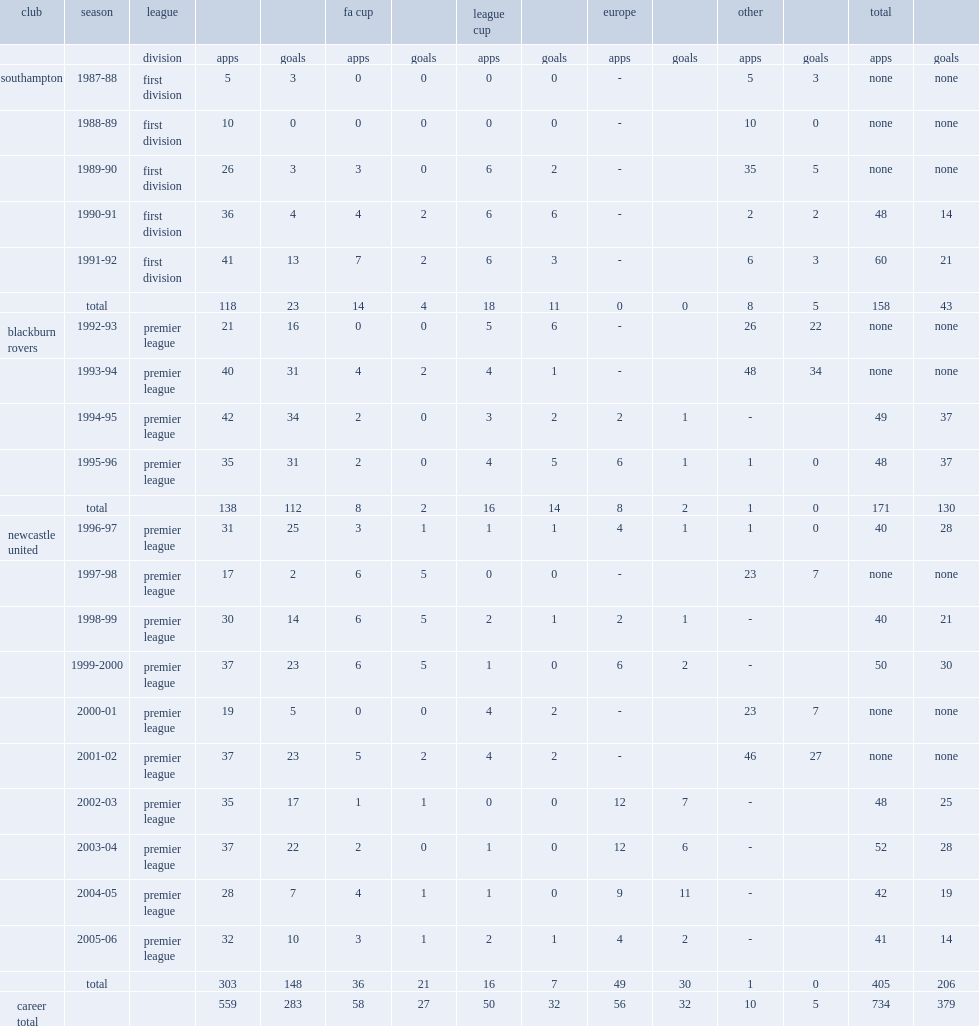How many league goals did alan sheare score for blackburn rovers? 112.0. 